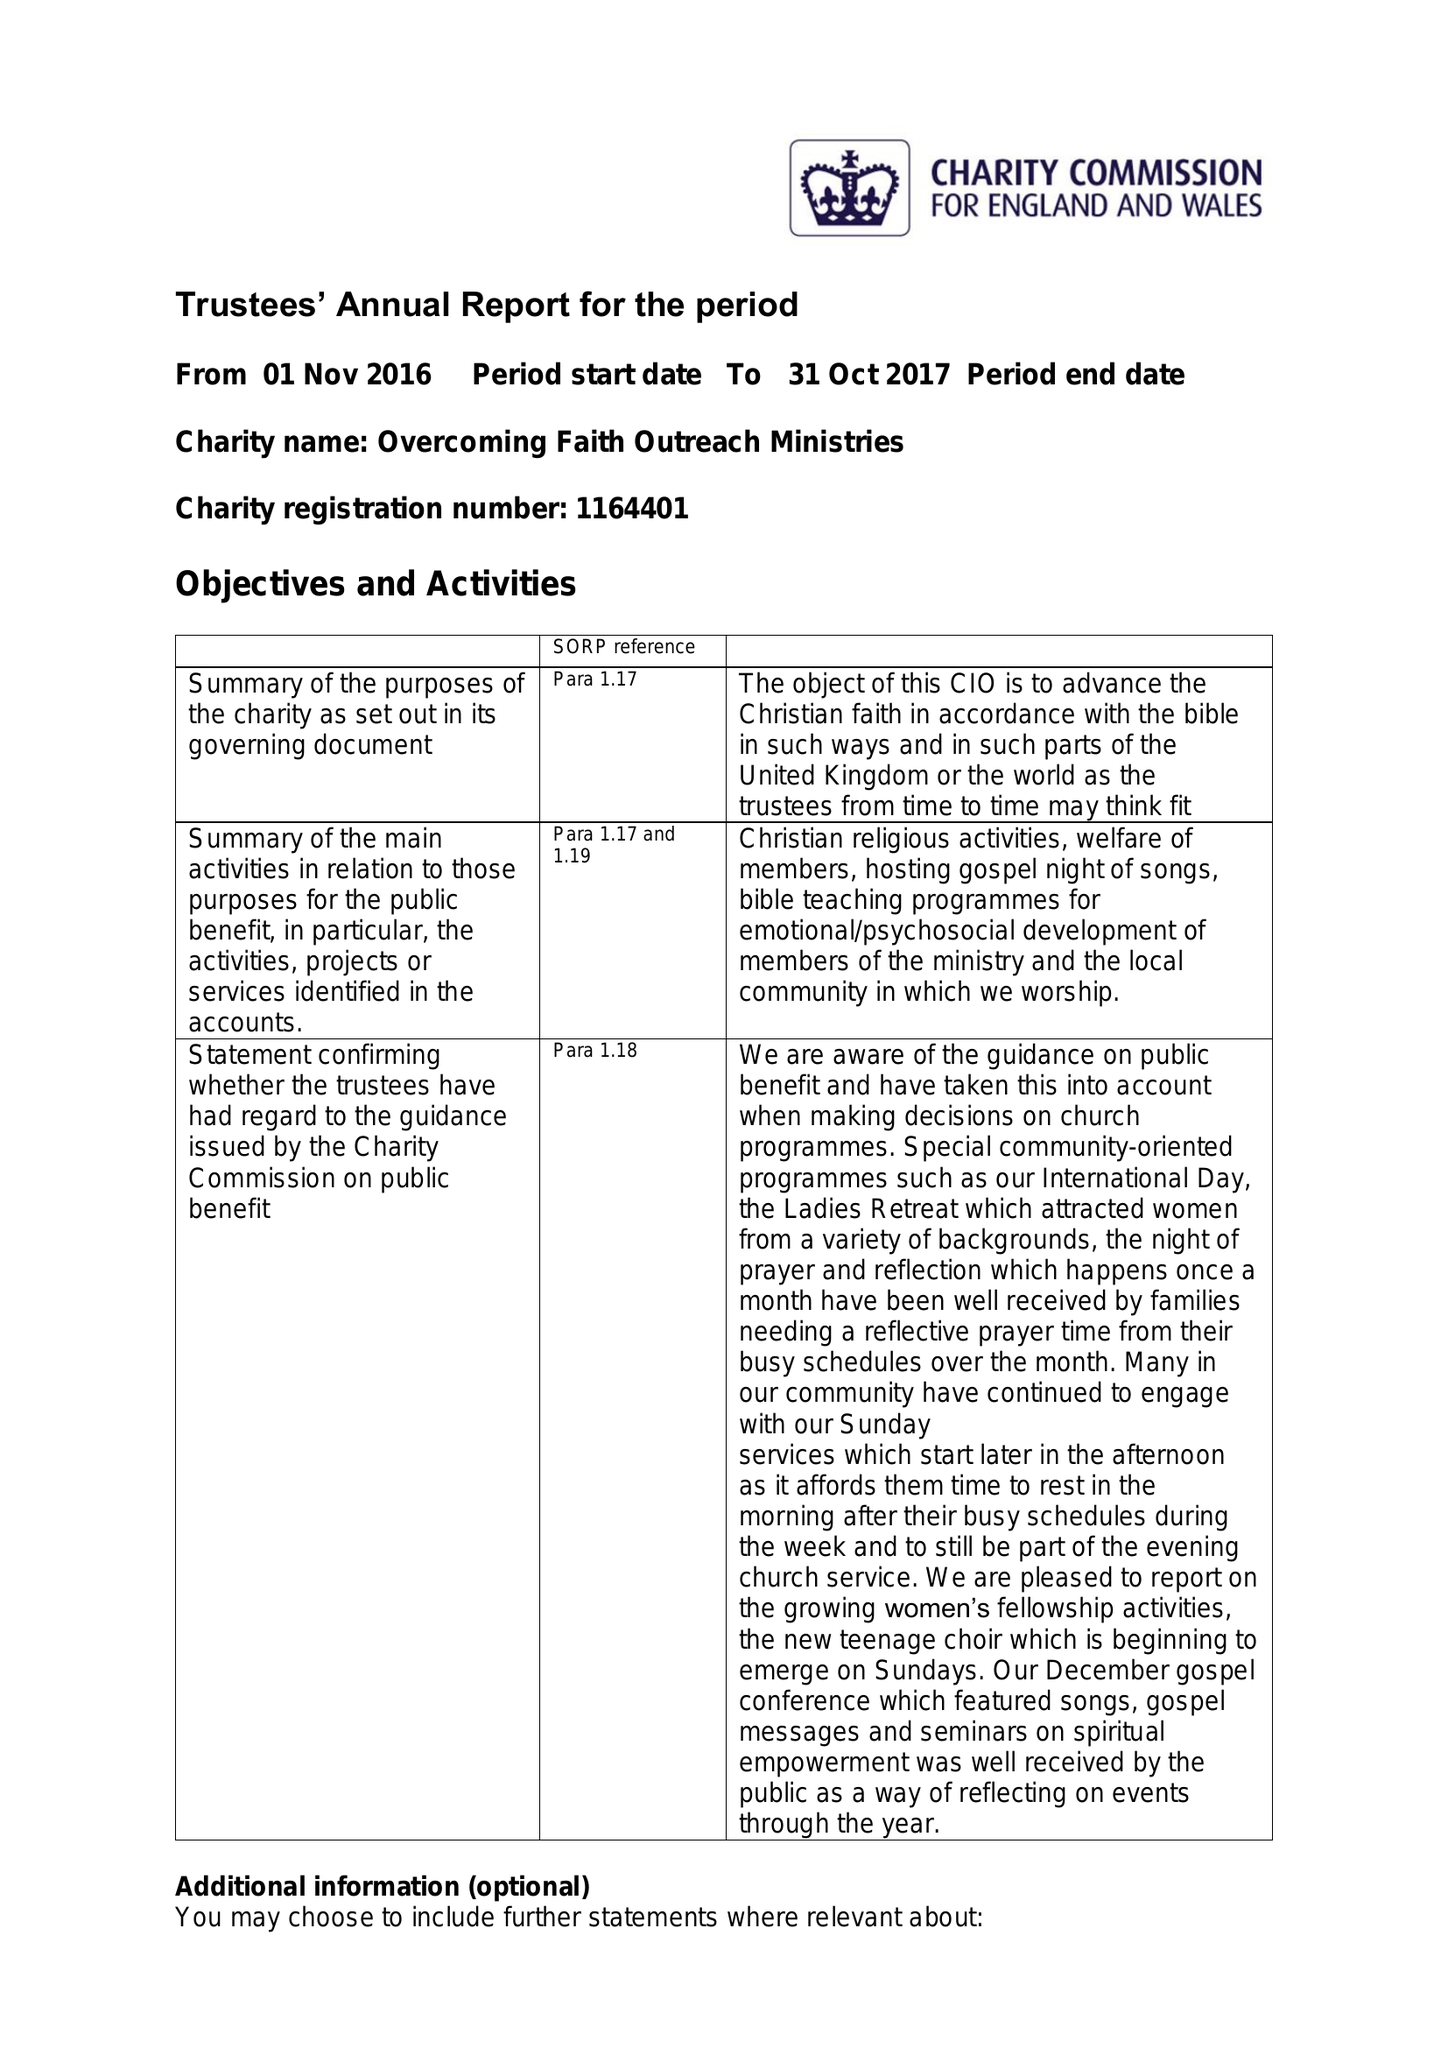What is the value for the report_date?
Answer the question using a single word or phrase. 2017-10-31 